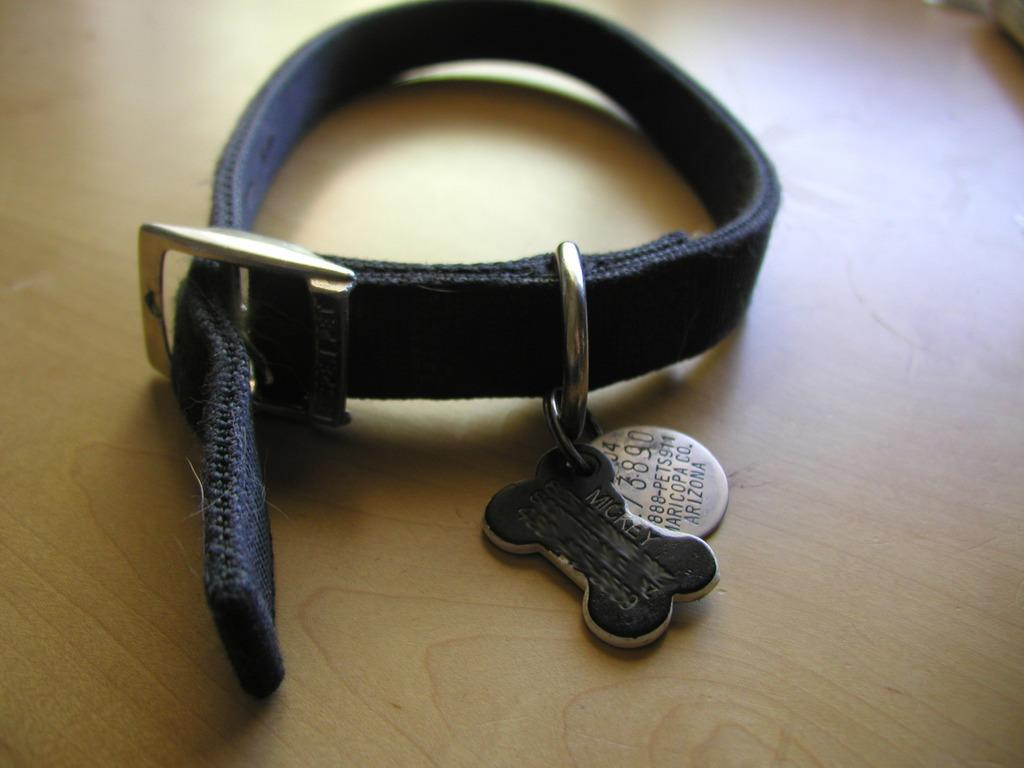What object related to a dog can be seen in the image? There is a dog collar in the image. Does the dog collar have any additional features? Yes, the dog collar has a name tag. Where are the dog collar and name tag located in the image? The dog collar and name tag are placed on a table. What type of winter clothing is visible in the image? There is no winter clothing present in the image; it features a dog collar and name tag on a table. What role does the minister play in the image? There is no minister present in the image; it features a dog collar and name tag on a table. 